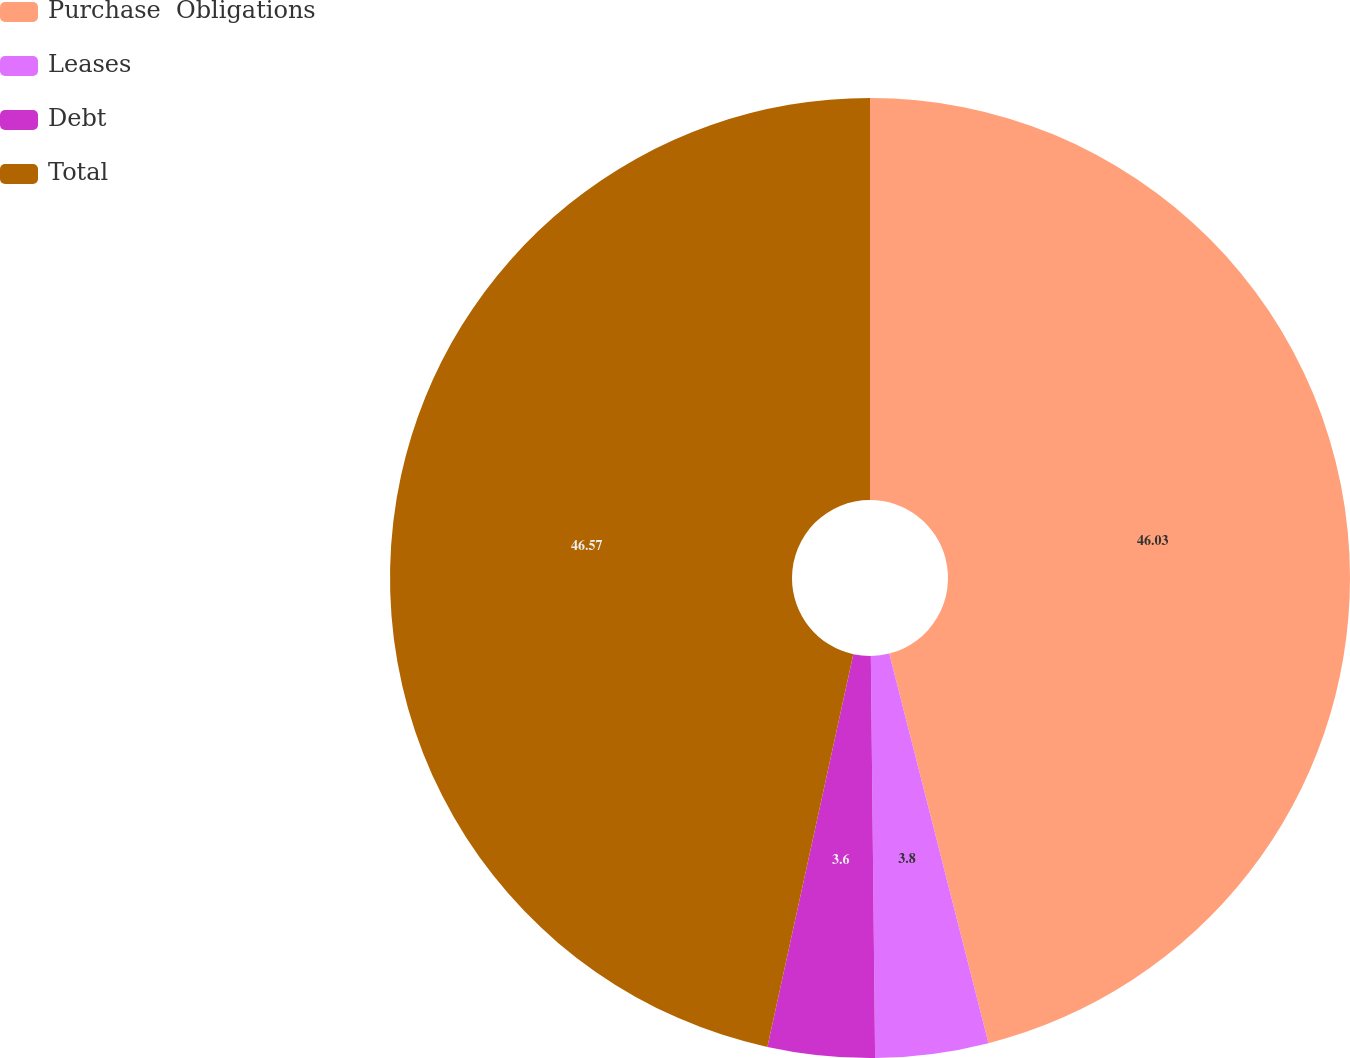Convert chart to OTSL. <chart><loc_0><loc_0><loc_500><loc_500><pie_chart><fcel>Purchase  Obligations<fcel>Leases<fcel>Debt<fcel>Total<nl><fcel>46.03%<fcel>3.8%<fcel>3.6%<fcel>46.57%<nl></chart> 